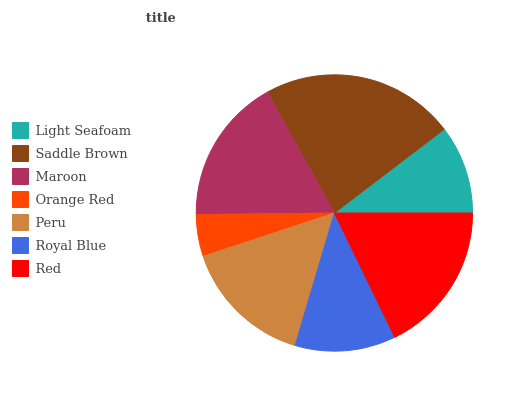Is Orange Red the minimum?
Answer yes or no. Yes. Is Saddle Brown the maximum?
Answer yes or no. Yes. Is Maroon the minimum?
Answer yes or no. No. Is Maroon the maximum?
Answer yes or no. No. Is Saddle Brown greater than Maroon?
Answer yes or no. Yes. Is Maroon less than Saddle Brown?
Answer yes or no. Yes. Is Maroon greater than Saddle Brown?
Answer yes or no. No. Is Saddle Brown less than Maroon?
Answer yes or no. No. Is Peru the high median?
Answer yes or no. Yes. Is Peru the low median?
Answer yes or no. Yes. Is Saddle Brown the high median?
Answer yes or no. No. Is Light Seafoam the low median?
Answer yes or no. No. 